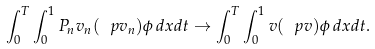Convert formula to latex. <formula><loc_0><loc_0><loc_500><loc_500>\int _ { 0 } ^ { T } \int _ { 0 } ^ { 1 } P _ { n } v _ { n } ( \ p v _ { n } ) \phi \, d x d t \rightarrow \int _ { 0 } ^ { T } \int _ { 0 } ^ { 1 } v ( \ p v ) \phi \, d x d t .</formula> 